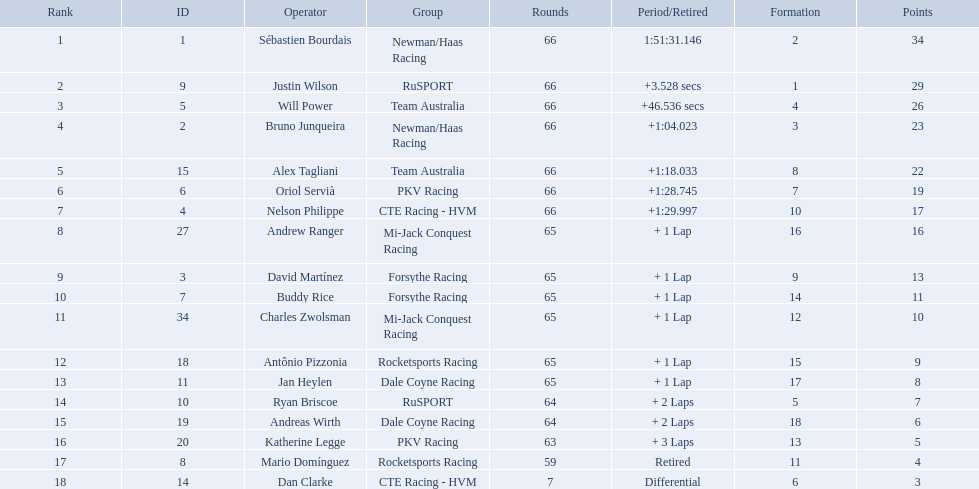Who are all of the 2006 gran premio telmex drivers? Sébastien Bourdais, Justin Wilson, Will Power, Bruno Junqueira, Alex Tagliani, Oriol Servià, Nelson Philippe, Andrew Ranger, David Martínez, Buddy Rice, Charles Zwolsman, Antônio Pizzonia, Jan Heylen, Ryan Briscoe, Andreas Wirth, Katherine Legge, Mario Domínguez, Dan Clarke. How many laps did they finish? 66, 66, 66, 66, 66, 66, 66, 65, 65, 65, 65, 65, 65, 64, 64, 63, 59, 7. What about just oriol servia and katherine legge? 66, 63. And which of those two drivers finished more laps? Oriol Servià. How many laps did oriol servia complete at the 2006 gran premio? 66. How many laps did katherine legge complete at the 2006 gran premio? 63. Between servia and legge, who completed more laps? Oriol Servià. Which people scored 29+ points? Sébastien Bourdais, Justin Wilson. Who scored higher? Sébastien Bourdais. What are the drivers numbers? 1, 9, 5, 2, 15, 6, 4, 27, 3, 7, 34, 18, 11, 10, 19, 20, 8, 14. Are there any who's number matches his position? Sébastien Bourdais, Oriol Servià. Can you give me this table as a dict? {'header': ['Rank', 'ID', 'Operator', 'Group', 'Rounds', 'Period/Retired', 'Formation', 'Points'], 'rows': [['1', '1', 'Sébastien Bourdais', 'Newman/Haas Racing', '66', '1:51:31.146', '2', '34'], ['2', '9', 'Justin Wilson', 'RuSPORT', '66', '+3.528 secs', '1', '29'], ['3', '5', 'Will Power', 'Team Australia', '66', '+46.536 secs', '4', '26'], ['4', '2', 'Bruno Junqueira', 'Newman/Haas Racing', '66', '+1:04.023', '3', '23'], ['5', '15', 'Alex Tagliani', 'Team Australia', '66', '+1:18.033', '8', '22'], ['6', '6', 'Oriol Servià', 'PKV Racing', '66', '+1:28.745', '7', '19'], ['7', '4', 'Nelson Philippe', 'CTE Racing - HVM', '66', '+1:29.997', '10', '17'], ['8', '27', 'Andrew Ranger', 'Mi-Jack Conquest Racing', '65', '+ 1 Lap', '16', '16'], ['9', '3', 'David Martínez', 'Forsythe Racing', '65', '+ 1 Lap', '9', '13'], ['10', '7', 'Buddy Rice', 'Forsythe Racing', '65', '+ 1 Lap', '14', '11'], ['11', '34', 'Charles Zwolsman', 'Mi-Jack Conquest Racing', '65', '+ 1 Lap', '12', '10'], ['12', '18', 'Antônio Pizzonia', 'Rocketsports Racing', '65', '+ 1 Lap', '15', '9'], ['13', '11', 'Jan Heylen', 'Dale Coyne Racing', '65', '+ 1 Lap', '17', '8'], ['14', '10', 'Ryan Briscoe', 'RuSPORT', '64', '+ 2 Laps', '5', '7'], ['15', '19', 'Andreas Wirth', 'Dale Coyne Racing', '64', '+ 2 Laps', '18', '6'], ['16', '20', 'Katherine Legge', 'PKV Racing', '63', '+ 3 Laps', '13', '5'], ['17', '8', 'Mario Domínguez', 'Rocketsports Racing', '59', 'Retired', '11', '4'], ['18', '14', 'Dan Clarke', 'CTE Racing - HVM', '7', 'Differential', '6', '3']]} Of those two who has the highest position? Sébastien Bourdais. Who are the drivers? Sébastien Bourdais, Justin Wilson, Will Power, Bruno Junqueira, Alex Tagliani, Oriol Servià, Nelson Philippe, Andrew Ranger, David Martínez, Buddy Rice, Charles Zwolsman, Antônio Pizzonia, Jan Heylen, Ryan Briscoe, Andreas Wirth, Katherine Legge, Mario Domínguez, Dan Clarke. What are their numbers? 1, 9, 5, 2, 15, 6, 4, 27, 3, 7, 34, 18, 11, 10, 19, 20, 8, 14. What are their positions? 1, 2, 3, 4, 5, 6, 7, 8, 9, 10, 11, 12, 13, 14, 15, 16, 17, 18. Which driver has the same number and position? Sébastien Bourdais. 